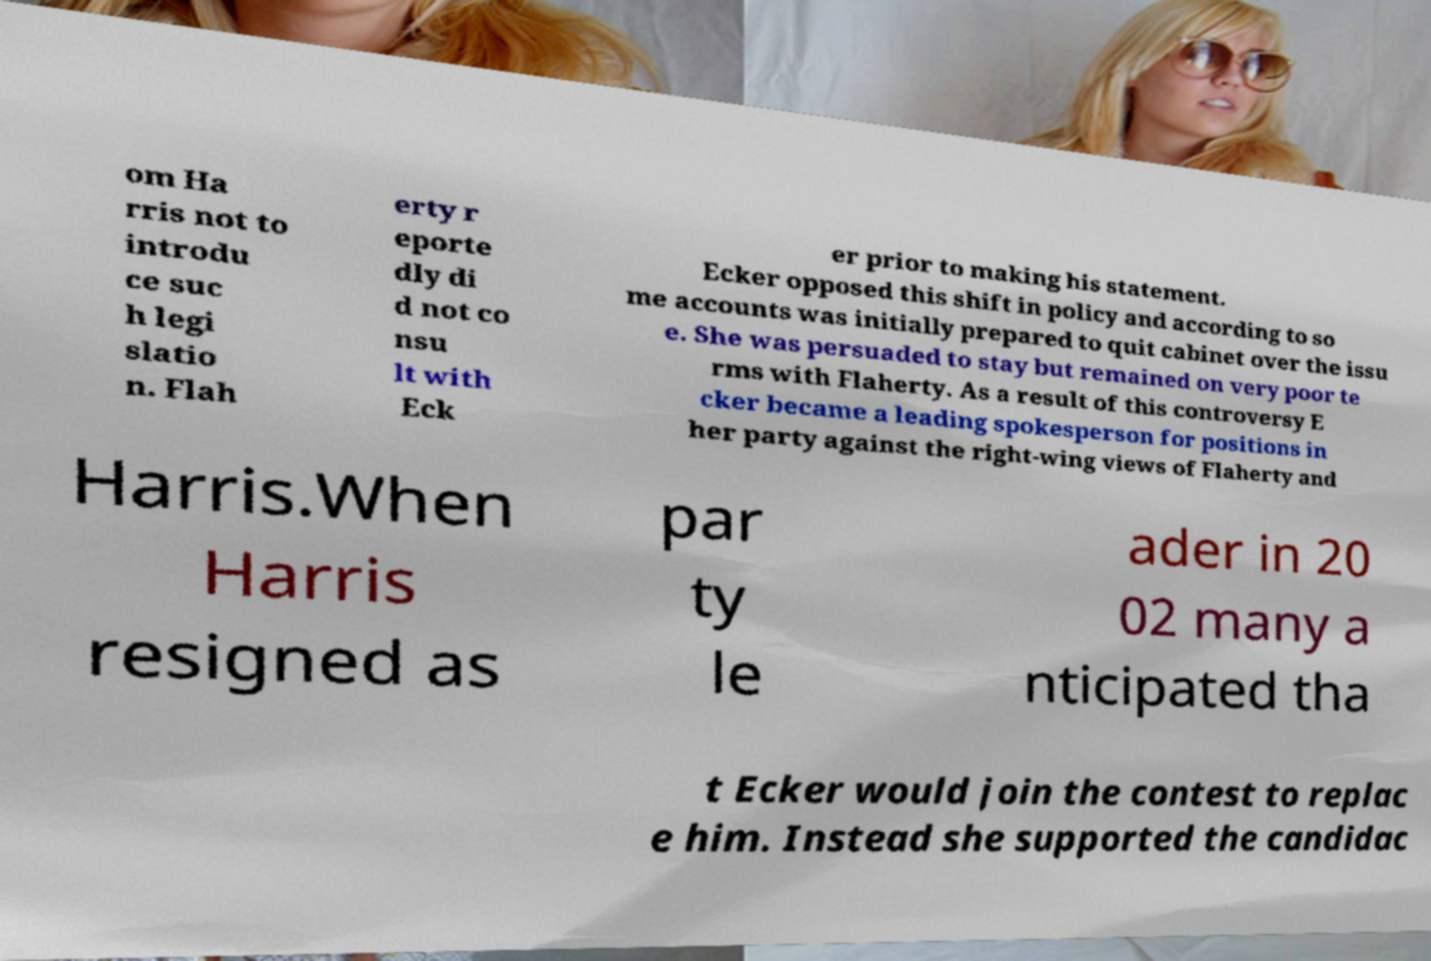What messages or text are displayed in this image? I need them in a readable, typed format. om Ha rris not to introdu ce suc h legi slatio n. Flah erty r eporte dly di d not co nsu lt with Eck er prior to making his statement. Ecker opposed this shift in policy and according to so me accounts was initially prepared to quit cabinet over the issu e. She was persuaded to stay but remained on very poor te rms with Flaherty. As a result of this controversy E cker became a leading spokesperson for positions in her party against the right-wing views of Flaherty and Harris.When Harris resigned as par ty le ader in 20 02 many a nticipated tha t Ecker would join the contest to replac e him. Instead she supported the candidac 